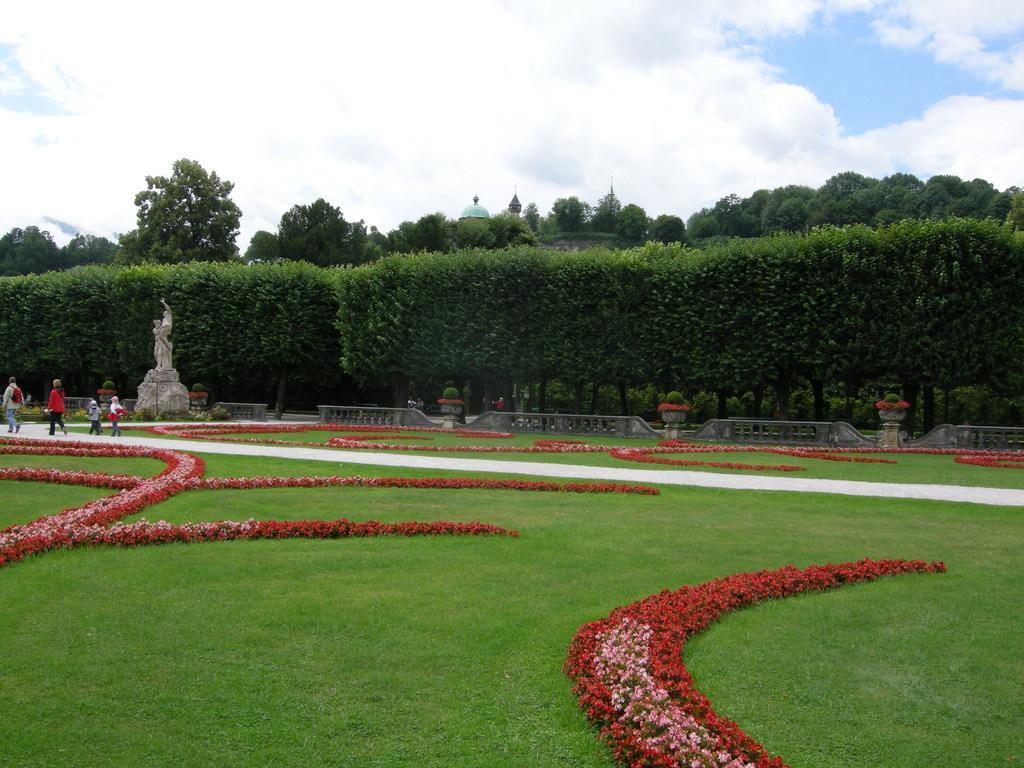Describe this image in one or two sentences. In this picture I can see there is grass on the floor and there are red and pink colored flowers, there are few trees in the backdrop and it looks like there is a building and the sky is clear. 